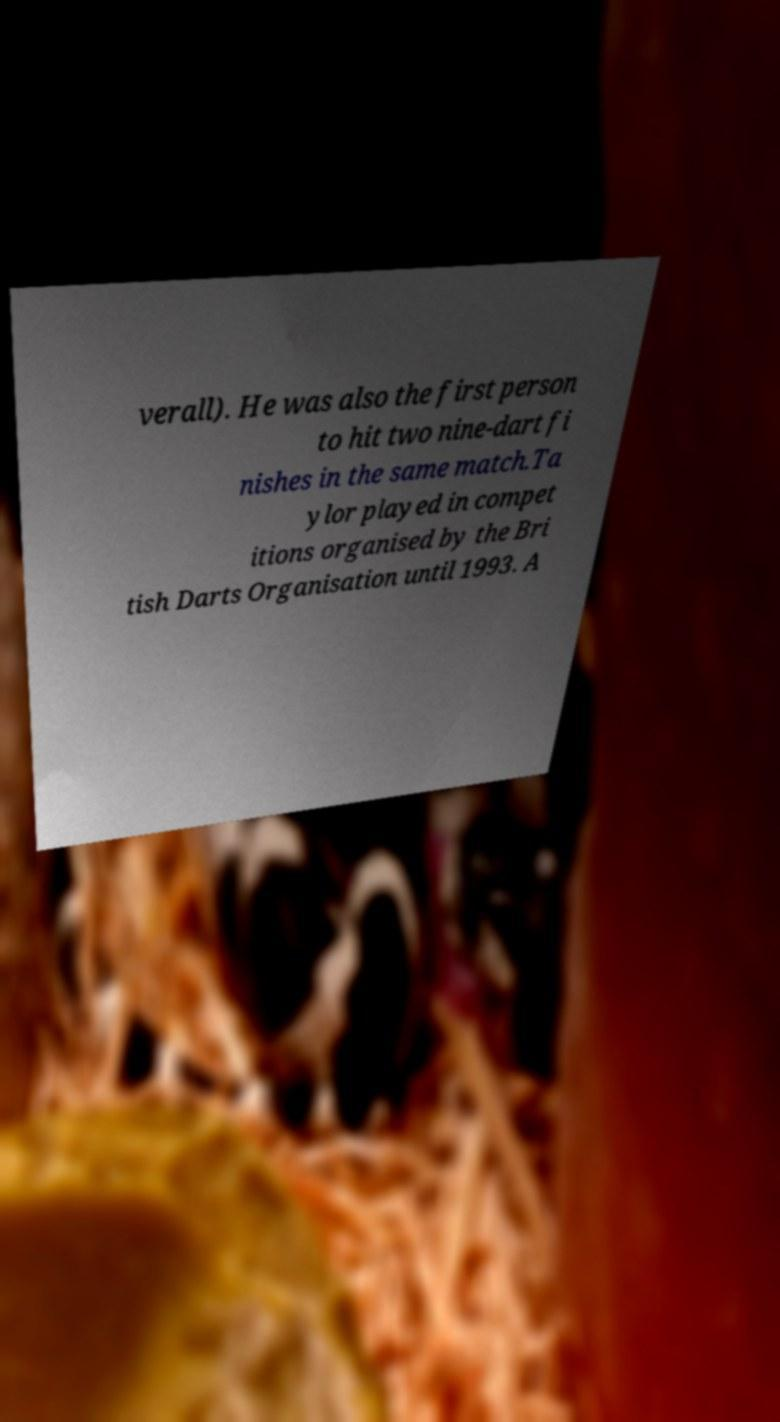Can you read and provide the text displayed in the image?This photo seems to have some interesting text. Can you extract and type it out for me? verall). He was also the first person to hit two nine-dart fi nishes in the same match.Ta ylor played in compet itions organised by the Bri tish Darts Organisation until 1993. A 